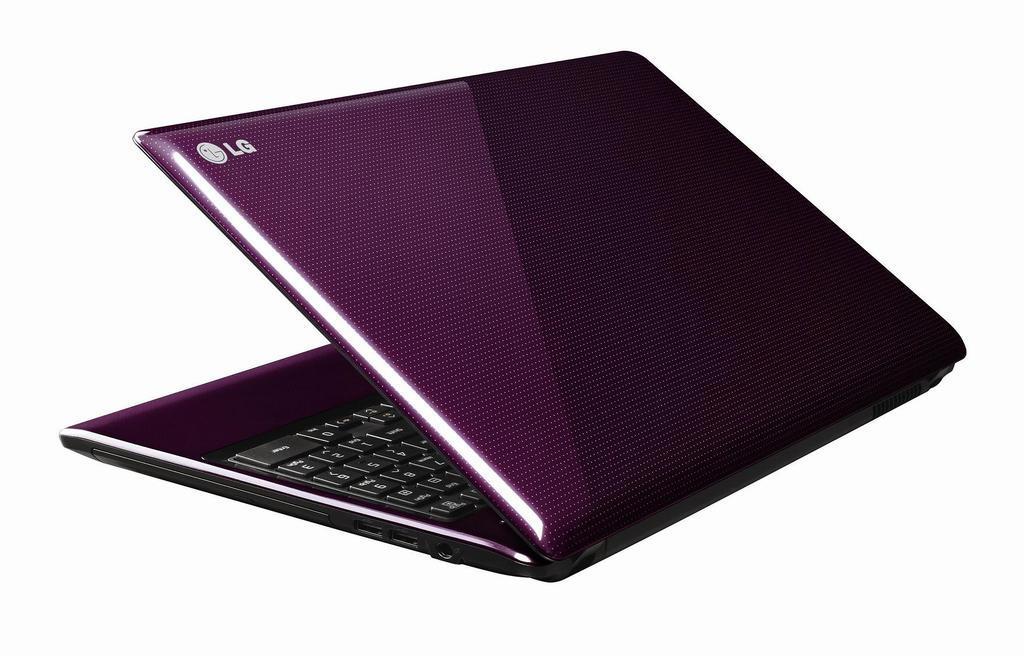Describe this image in one or two sentences. In this image we can see a laptop. The laptop is in the color of pink. The brand name is mentioned as "LG". 